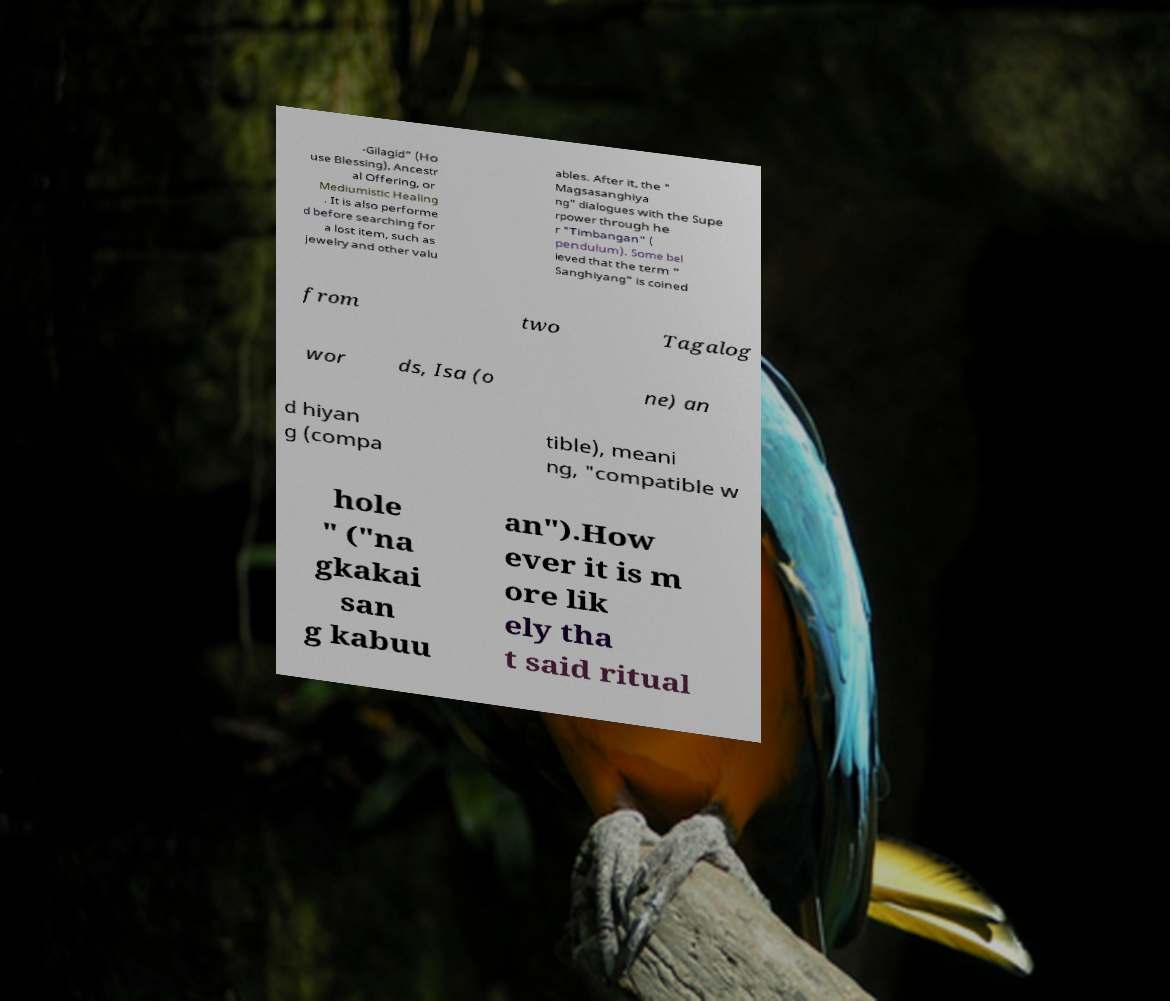I need the written content from this picture converted into text. Can you do that? -Gilagid" (Ho use Blessing), Ancestr al Offering, or Mediumistic Healing . It is also performe d before searching for a lost item, such as jewelry and other valu ables. After it, the " Magsasanghiya ng" dialogues with the Supe rpower through he r "Timbangan" ( pendulum). Some bel ieved that the term " Sanghiyang" is coined from two Tagalog wor ds, Isa (o ne) an d hiyan g (compa tible), meani ng, "compatible w hole " ("na gkakai san g kabuu an").How ever it is m ore lik ely tha t said ritual 